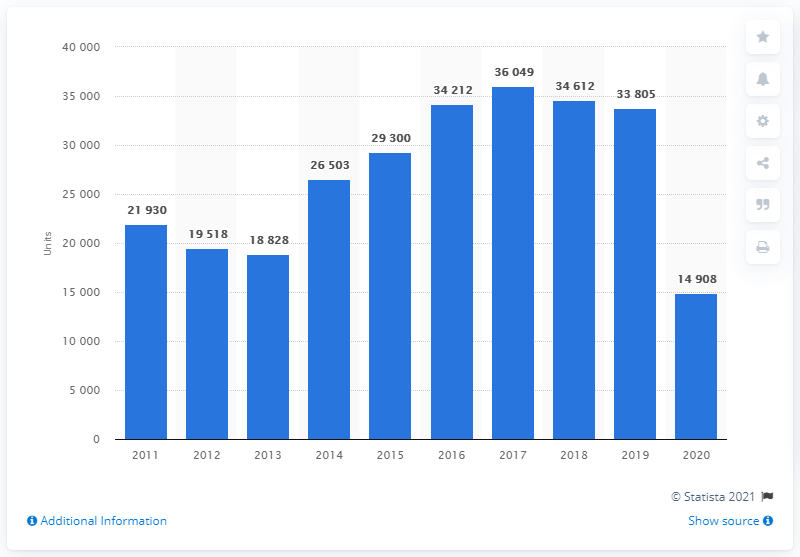List a handful of essential elements in this visual. In 2020, a total of 14,908 new Opel cars were registered in Poland. In 2013, there were a total of 18,828 Polish-registered Opel cars. In the year 2011, a total of 21,930 new Opel cars were registered in Poland. 